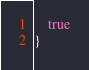Convert code to text. <code><loc_0><loc_0><loc_500><loc_500><_Scala_>    true
}
</code> 